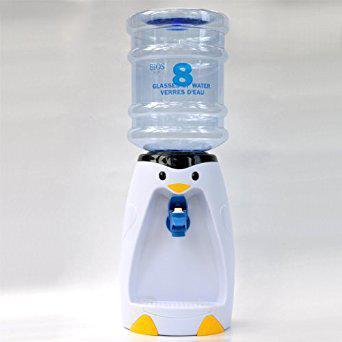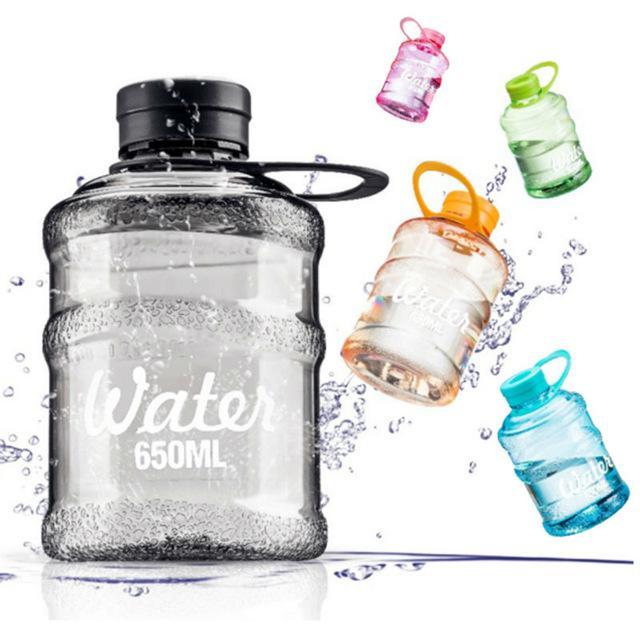The first image is the image on the left, the second image is the image on the right. Given the left and right images, does the statement "In at least one image there is a single water bottle twisted into a penguin water dispenser." hold true? Answer yes or no. Yes. The first image is the image on the left, the second image is the image on the right. Analyze the images presented: Is the assertion "The right image shows an inverted blue water jug, and the left image includes a water jug and a dispenser that looks like a penguin." valid? Answer yes or no. No. 